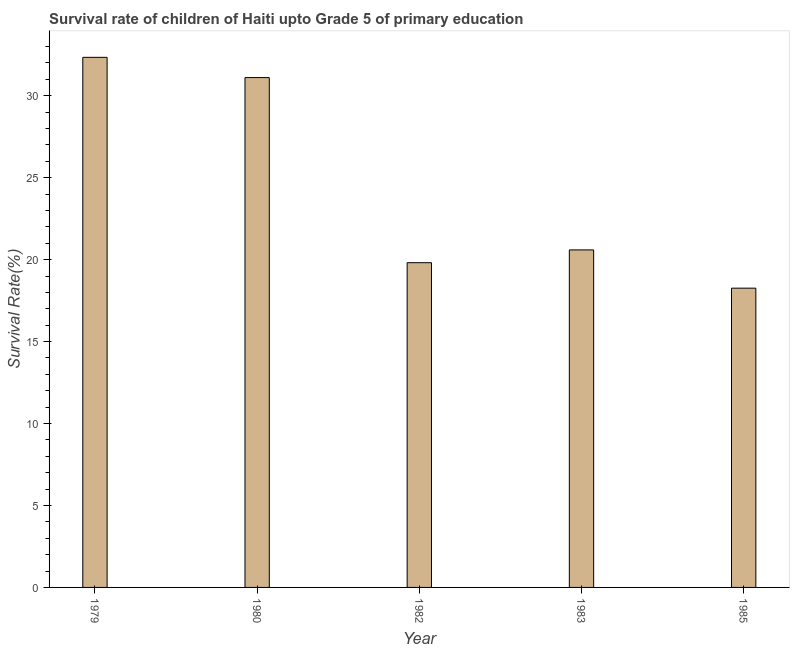Does the graph contain grids?
Offer a very short reply. No. What is the title of the graph?
Offer a terse response. Survival rate of children of Haiti upto Grade 5 of primary education. What is the label or title of the Y-axis?
Offer a very short reply. Survival Rate(%). What is the survival rate in 1985?
Your answer should be very brief. 18.26. Across all years, what is the maximum survival rate?
Your answer should be very brief. 32.34. Across all years, what is the minimum survival rate?
Make the answer very short. 18.26. In which year was the survival rate maximum?
Ensure brevity in your answer.  1979. In which year was the survival rate minimum?
Provide a succinct answer. 1985. What is the sum of the survival rate?
Keep it short and to the point. 122.11. What is the difference between the survival rate in 1979 and 1982?
Provide a short and direct response. 12.53. What is the average survival rate per year?
Give a very brief answer. 24.42. What is the median survival rate?
Your answer should be compact. 20.59. Do a majority of the years between 1983 and 1980 (inclusive) have survival rate greater than 10 %?
Your answer should be very brief. Yes. What is the difference between the highest and the second highest survival rate?
Provide a succinct answer. 1.24. Is the sum of the survival rate in 1979 and 1983 greater than the maximum survival rate across all years?
Provide a short and direct response. Yes. What is the difference between the highest and the lowest survival rate?
Give a very brief answer. 14.08. How many bars are there?
Ensure brevity in your answer.  5. Are all the bars in the graph horizontal?
Your answer should be compact. No. What is the difference between two consecutive major ticks on the Y-axis?
Your response must be concise. 5. Are the values on the major ticks of Y-axis written in scientific E-notation?
Provide a short and direct response. No. What is the Survival Rate(%) in 1979?
Provide a succinct answer. 32.34. What is the Survival Rate(%) of 1980?
Provide a short and direct response. 31.11. What is the Survival Rate(%) in 1982?
Your answer should be compact. 19.81. What is the Survival Rate(%) in 1983?
Offer a very short reply. 20.59. What is the Survival Rate(%) of 1985?
Give a very brief answer. 18.26. What is the difference between the Survival Rate(%) in 1979 and 1980?
Your answer should be compact. 1.24. What is the difference between the Survival Rate(%) in 1979 and 1982?
Offer a terse response. 12.53. What is the difference between the Survival Rate(%) in 1979 and 1983?
Provide a short and direct response. 11.75. What is the difference between the Survival Rate(%) in 1979 and 1985?
Offer a very short reply. 14.08. What is the difference between the Survival Rate(%) in 1980 and 1982?
Provide a short and direct response. 11.29. What is the difference between the Survival Rate(%) in 1980 and 1983?
Ensure brevity in your answer.  10.51. What is the difference between the Survival Rate(%) in 1980 and 1985?
Keep it short and to the point. 12.85. What is the difference between the Survival Rate(%) in 1982 and 1983?
Your answer should be compact. -0.78. What is the difference between the Survival Rate(%) in 1982 and 1985?
Your answer should be very brief. 1.55. What is the difference between the Survival Rate(%) in 1983 and 1985?
Offer a terse response. 2.33. What is the ratio of the Survival Rate(%) in 1979 to that in 1980?
Give a very brief answer. 1.04. What is the ratio of the Survival Rate(%) in 1979 to that in 1982?
Your response must be concise. 1.63. What is the ratio of the Survival Rate(%) in 1979 to that in 1983?
Your answer should be compact. 1.57. What is the ratio of the Survival Rate(%) in 1979 to that in 1985?
Offer a terse response. 1.77. What is the ratio of the Survival Rate(%) in 1980 to that in 1982?
Your answer should be very brief. 1.57. What is the ratio of the Survival Rate(%) in 1980 to that in 1983?
Your answer should be compact. 1.51. What is the ratio of the Survival Rate(%) in 1980 to that in 1985?
Offer a terse response. 1.7. What is the ratio of the Survival Rate(%) in 1982 to that in 1985?
Offer a very short reply. 1.08. What is the ratio of the Survival Rate(%) in 1983 to that in 1985?
Make the answer very short. 1.13. 